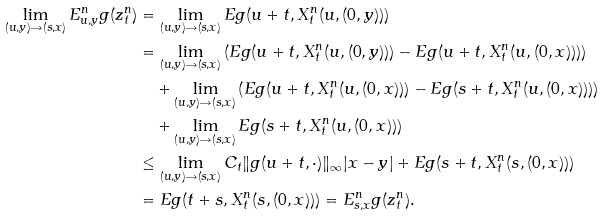<formula> <loc_0><loc_0><loc_500><loc_500>\lim _ { ( u , y ) \rightarrow ( s , x ) } E _ { u , y } ^ { n } g ( z _ { t } ^ { n } ) & = \lim _ { ( u , y ) \rightarrow ( s , x ) } E g ( u + t , X ^ { n } _ { t } ( u , ( 0 , y ) ) ) \\ & = \lim _ { ( u , y ) \rightarrow ( s , x ) } \left ( E g ( u + t , X ^ { n } _ { t } ( u , ( 0 , y ) ) ) - E g ( u + t , X ^ { n } _ { t } ( u , ( 0 , x ) ) ) \right ) \\ & \quad + \lim _ { ( u , y ) \rightarrow ( s , x ) } \left ( E g ( u + t , X ^ { n } _ { t } ( u , ( 0 , x ) ) ) - E g ( s + t , X ^ { n } _ { t } ( u , ( 0 , x ) ) ) \right ) \\ & \quad + \lim _ { ( u , y ) \rightarrow ( s , x ) } E g ( s + t , X ^ { n } _ { t } ( u , ( 0 , x ) ) ) \\ & \leq \lim _ { ( u , y ) \rightarrow ( s , x ) } C _ { t } \| g ( u + t , \cdot ) \| _ { \infty } | x - y | + E g ( s + t , X ^ { n } _ { t } ( s , ( 0 , x ) ) ) \\ & = E g ( t + s , X ^ { n } _ { t } ( s , ( 0 , x ) ) ) = E _ { s , x } ^ { n } g ( z _ { t } ^ { n } ) .</formula> 